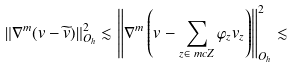Convert formula to latex. <formula><loc_0><loc_0><loc_500><loc_500>\| \nabla ^ { m } ( v - \widetilde { v } ) \| ^ { 2 } _ { O _ { h } } & \lesssim \left \| \nabla ^ { m } \left ( v - \sum _ { z \in \ m c Z } \varphi _ { z } v _ { z } \right ) \right \| ^ { 2 } _ { O _ { h } } \lesssim</formula> 